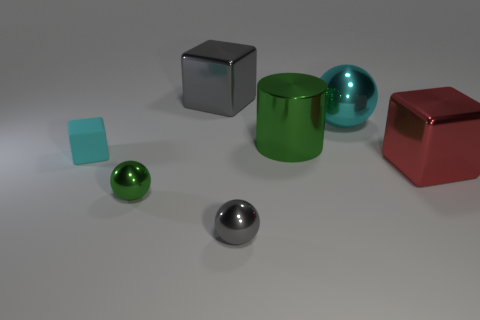What number of things are either green things behind the matte thing or large shiny objects that are in front of the matte thing?
Keep it short and to the point. 2. The tiny rubber object that is the same color as the big ball is what shape?
Ensure brevity in your answer.  Cube. There is a green metallic thing to the left of the tiny gray metallic sphere; what shape is it?
Your answer should be very brief. Sphere. Is the shape of the green object behind the small cyan matte block the same as  the small gray thing?
Your answer should be compact. No. How many things are shiny cubes that are left of the red metal block or small gray objects?
Provide a succinct answer. 2. There is a matte thing that is the same shape as the big red metallic object; what is its color?
Your answer should be very brief. Cyan. Are there any other things that have the same color as the tiny rubber block?
Your answer should be very brief. Yes. How big is the ball that is behind the red metal thing?
Your response must be concise. Large. Is the color of the cylinder the same as the tiny sphere that is on the left side of the large gray metallic thing?
Provide a short and direct response. Yes. How many other objects are the same material as the small cyan thing?
Keep it short and to the point. 0. 